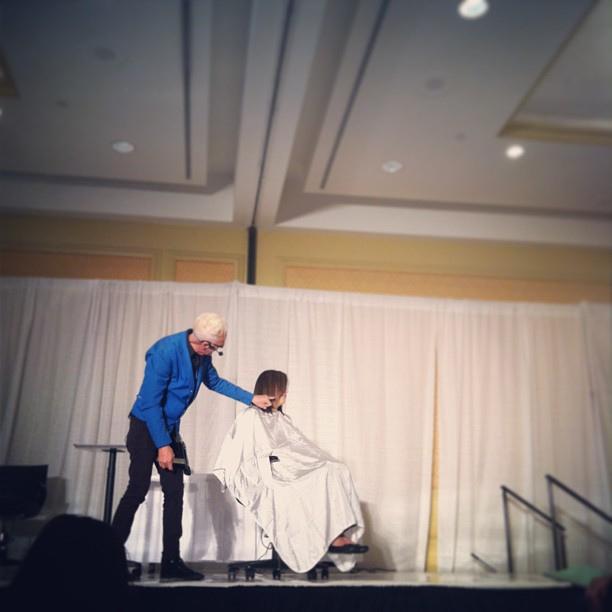Is this a meeting?
Answer briefly. No. What is the man doing with the person under the blanket?
Be succinct. Cutting hair. What is the white thing covering the person sitting?
Be succinct. Sheet. What is being cut?
Concise answer only. Hair. What are the kids sitting on?
Answer briefly. Chair. Why are there stair rails?
Keep it brief. Safety. What is the color of the woman's gown?
Keep it brief. White. 